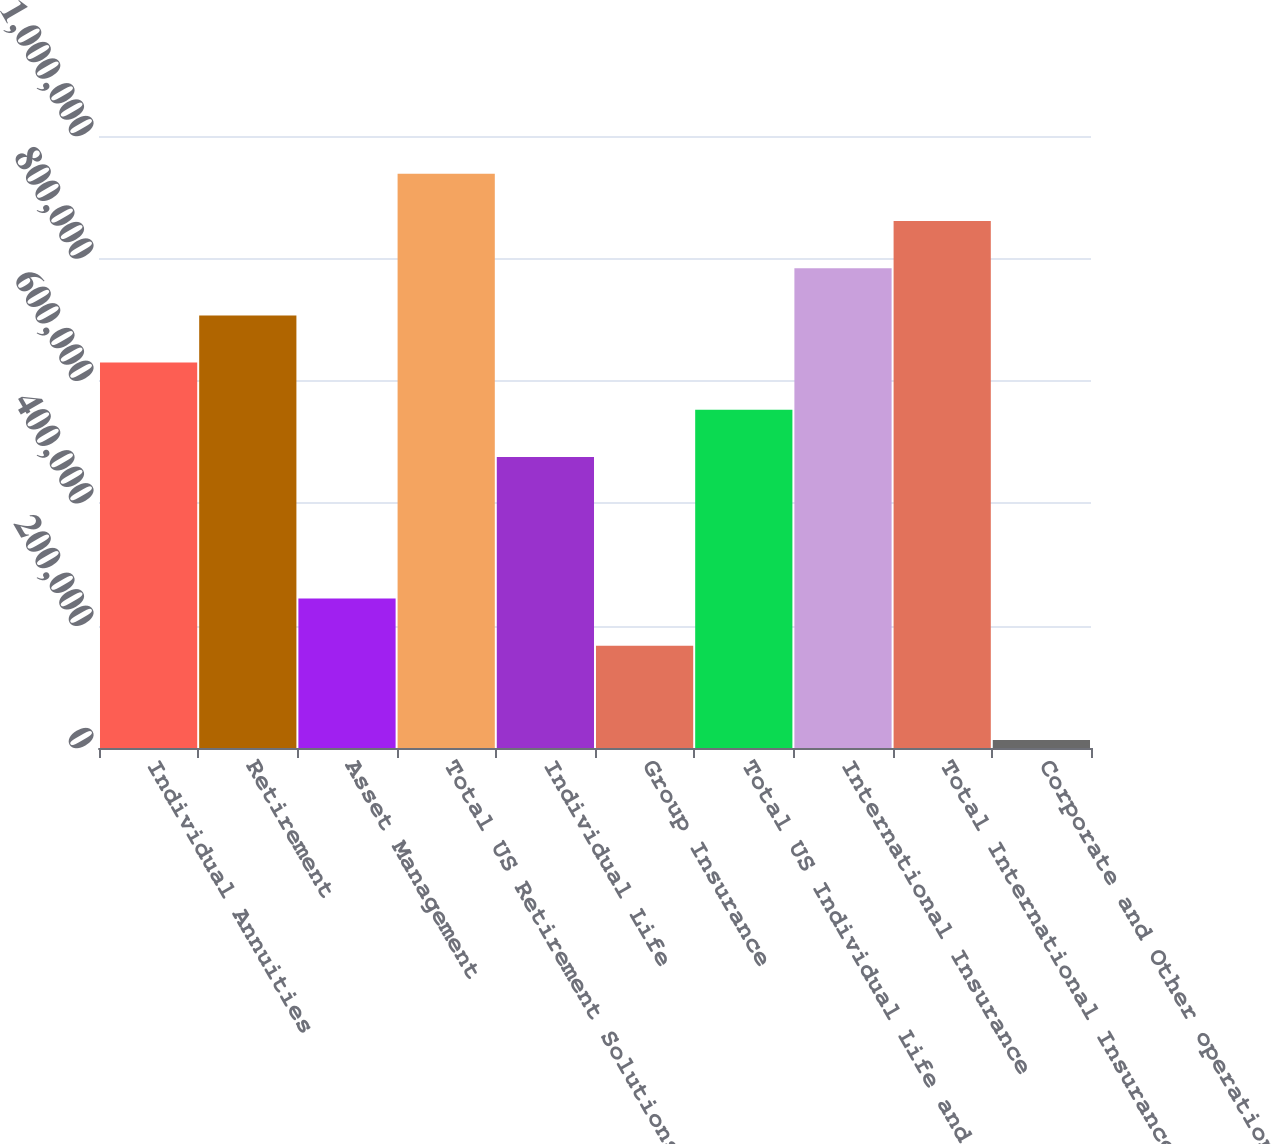Convert chart. <chart><loc_0><loc_0><loc_500><loc_500><bar_chart><fcel>Individual Annuities<fcel>Retirement<fcel>Asset Management<fcel>Total US Retirement Solutions<fcel>Individual Life<fcel>Group Insurance<fcel>Total US Individual Life and<fcel>International Insurance<fcel>Total International Insurance<fcel>Corporate and Other operations<nl><fcel>629770<fcel>706866<fcel>244289<fcel>938154<fcel>475578<fcel>167193<fcel>552674<fcel>783962<fcel>861058<fcel>13001<nl></chart> 